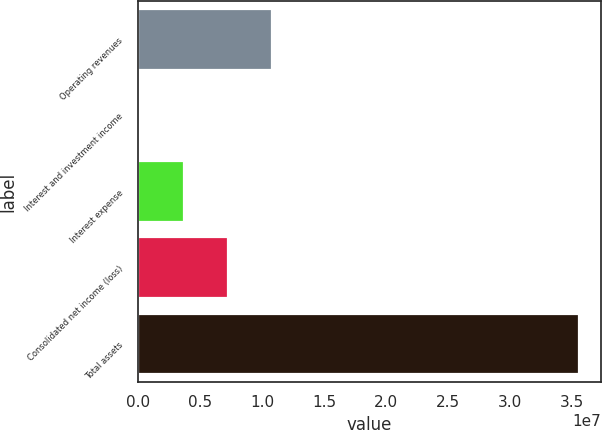Convert chart to OTSL. <chart><loc_0><loc_0><loc_500><loc_500><bar_chart><fcel>Operating revenues<fcel>Interest and investment income<fcel>Interest expense<fcel>Consolidated net income (loss)<fcel>Total assets<nl><fcel>1.07926e+07<fcel>186724<fcel>3.72201e+06<fcel>7.2573e+06<fcel>3.55396e+07<nl></chart> 